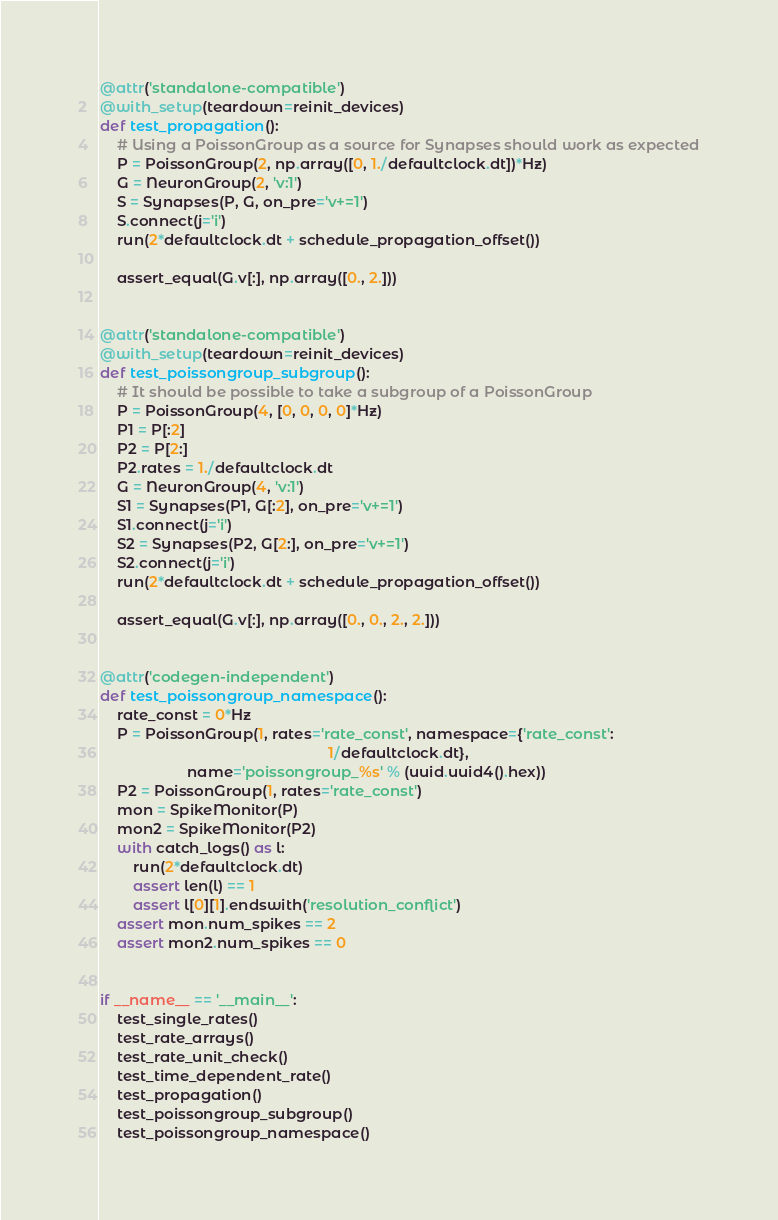Convert code to text. <code><loc_0><loc_0><loc_500><loc_500><_Python_>
@attr('standalone-compatible')
@with_setup(teardown=reinit_devices)
def test_propagation():
    # Using a PoissonGroup as a source for Synapses should work as expected
    P = PoissonGroup(2, np.array([0, 1./defaultclock.dt])*Hz)
    G = NeuronGroup(2, 'v:1')
    S = Synapses(P, G, on_pre='v+=1')
    S.connect(j='i')
    run(2*defaultclock.dt + schedule_propagation_offset())

    assert_equal(G.v[:], np.array([0., 2.]))


@attr('standalone-compatible')
@with_setup(teardown=reinit_devices)
def test_poissongroup_subgroup():
    # It should be possible to take a subgroup of a PoissonGroup
    P = PoissonGroup(4, [0, 0, 0, 0]*Hz)
    P1 = P[:2]
    P2 = P[2:]
    P2.rates = 1./defaultclock.dt
    G = NeuronGroup(4, 'v:1')
    S1 = Synapses(P1, G[:2], on_pre='v+=1')
    S1.connect(j='i')
    S2 = Synapses(P2, G[2:], on_pre='v+=1')
    S2.connect(j='i')
    run(2*defaultclock.dt + schedule_propagation_offset())

    assert_equal(G.v[:], np.array([0., 0., 2., 2.]))


@attr('codegen-independent')
def test_poissongroup_namespace():
    rate_const = 0*Hz
    P = PoissonGroup(1, rates='rate_const', namespace={'rate_const':
                                                       1/defaultclock.dt},
                     name='poissongroup_%s' % (uuid.uuid4().hex))
    P2 = PoissonGroup(1, rates='rate_const')
    mon = SpikeMonitor(P)
    mon2 = SpikeMonitor(P2)
    with catch_logs() as l:
        run(2*defaultclock.dt)
        assert len(l) == 1
        assert l[0][1].endswith('resolution_conflict')
    assert mon.num_spikes == 2
    assert mon2.num_spikes == 0


if __name__ == '__main__':
    test_single_rates()
    test_rate_arrays()
    test_rate_unit_check()
    test_time_dependent_rate()
    test_propagation()
    test_poissongroup_subgroup()
    test_poissongroup_namespace()
</code> 